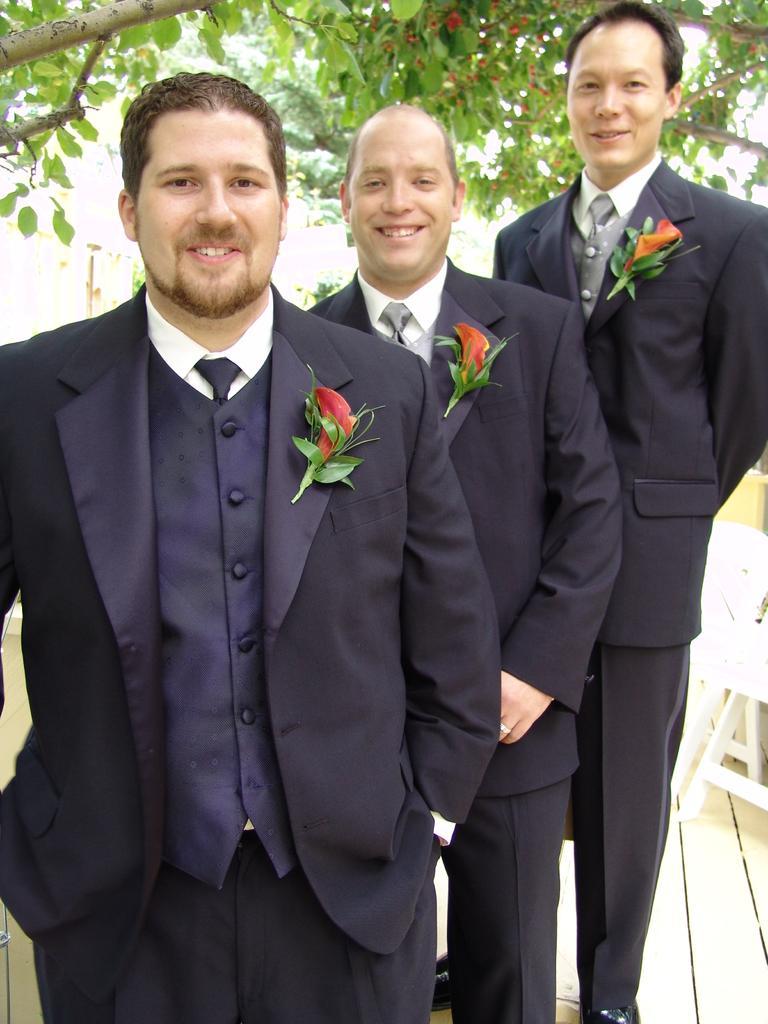How would you summarize this image in a sentence or two? In the picture we can see three men are standing one after the other and they are wearing blazers, ties and shirts and to the blazers we can see flowers are pasted. 